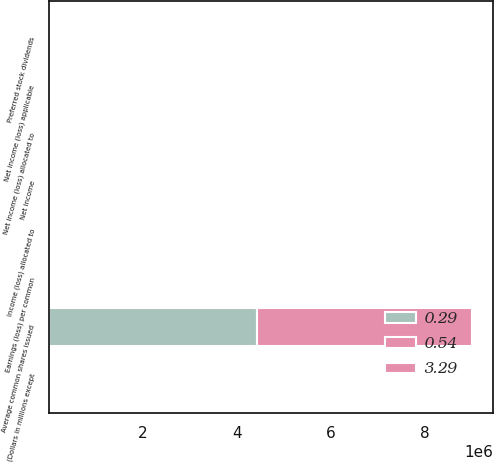<chart> <loc_0><loc_0><loc_500><loc_500><stacked_bar_chart><ecel><fcel>(Dollars in millions except<fcel>Net income<fcel>Preferred stock dividends<fcel>Net income (loss) applicable<fcel>Income (loss) allocated to<fcel>Net income (loss) allocated to<fcel>Average common shares issued<fcel>Earnings (loss) per common<nl><fcel>3.29<fcel>2009<fcel>6276<fcel>4494<fcel>2204<fcel>6<fcel>2210<fcel>2204<fcel>0.29<nl><fcel>0.54<fcel>2008<fcel>4008<fcel>1452<fcel>2556<fcel>69<fcel>2487<fcel>4.59208e+06<fcel>0.54<nl><fcel>0.29<fcel>2007<fcel>14982<fcel>182<fcel>14800<fcel>108<fcel>14692<fcel>4.42358e+06<fcel>3.32<nl></chart> 